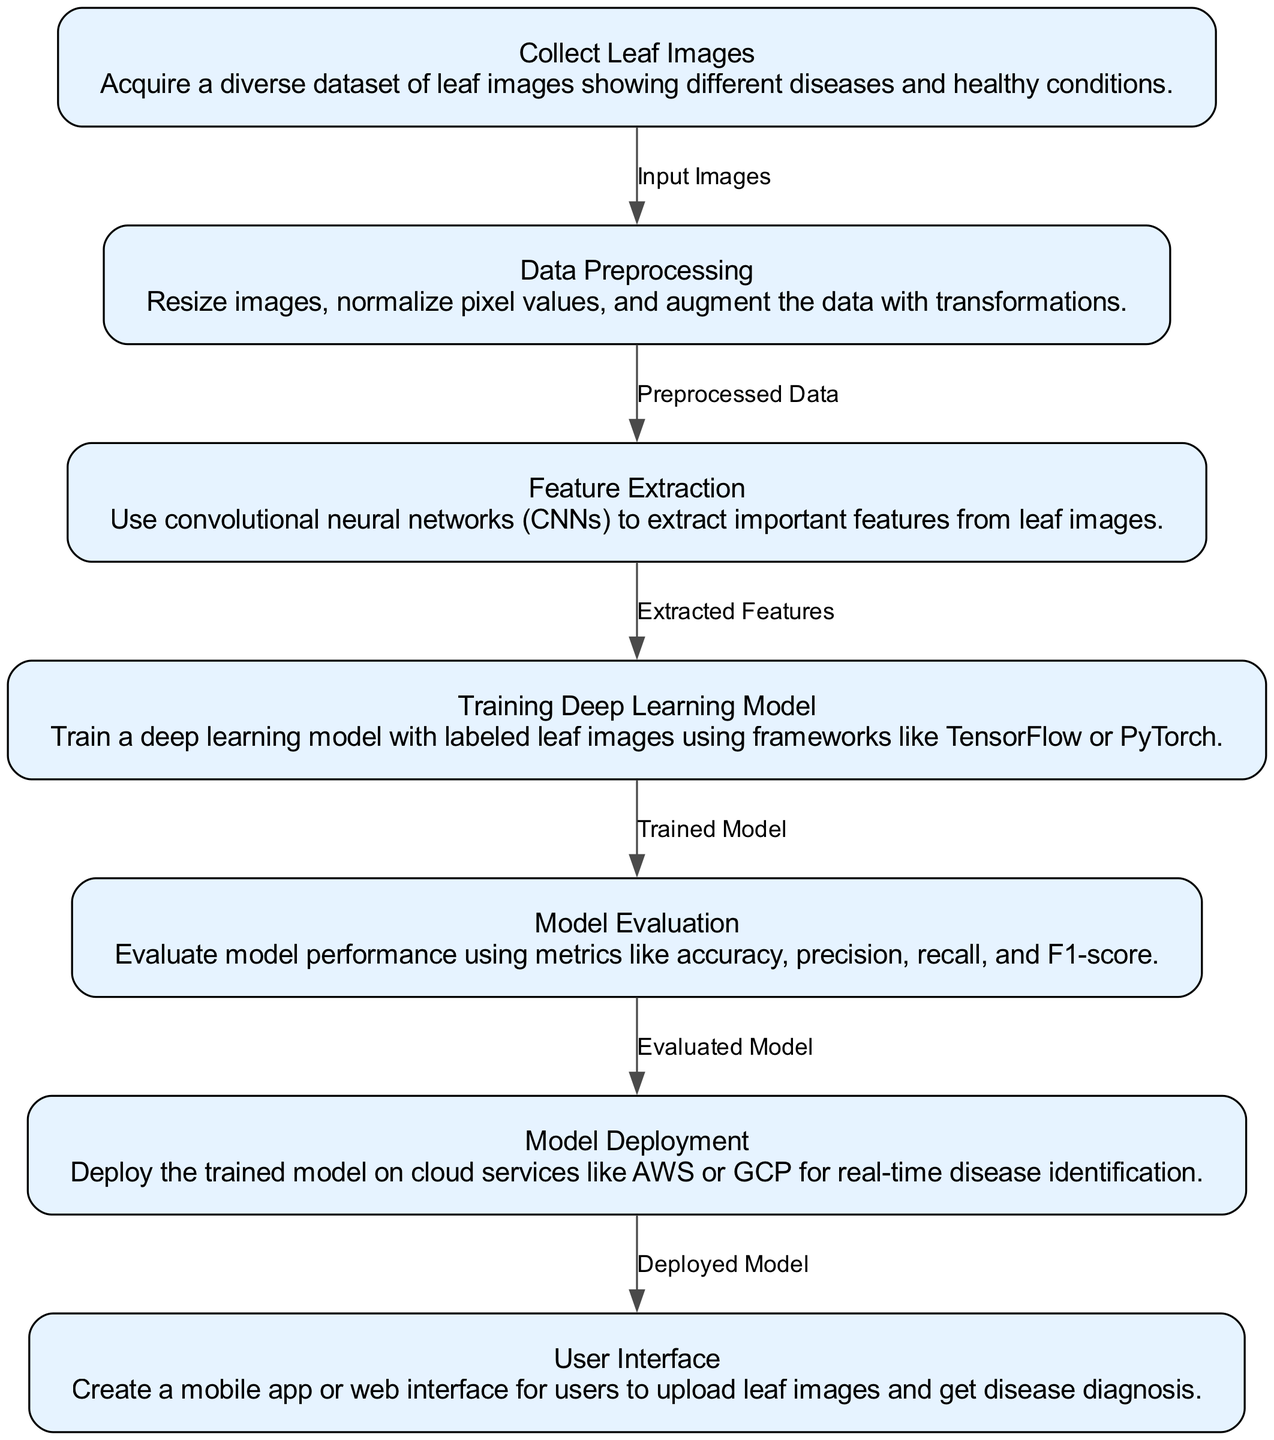What is the first step in the diagram? The first step in the diagram is "Collect Leaf Images", indicating that acquiring images is the initial action in the workflow.
Answer: Collect Leaf Images How many nodes are there in the diagram? By counting all the distinct steps shown in the diagram, there are a total of seven nodes representing different stages.
Answer: 7 What is the output of the "Data Preprocessing" node? The output of the "Data Preprocessing" node is "Preprocessed Data", which represents the transformed images ready for the next step in the process.
Answer: Preprocessed Data Which node comes after "Model Evaluation"? The node that comes after "Model Evaluation" is "Model Deployment", showing the progression from evaluating the model to deploying it for practical use.
Answer: Model Deployment What technique is used in "Feature Extraction"? The technique used in "Feature Extraction" is "convolutional neural networks (CNNs)", which are specifically designed for processing image data to extract features.
Answer: convolutional neural networks What are the metrics mentioned for "Model Evaluation"? The metrics mentioned for "Model Evaluation" include accuracy, precision, recall, and F1-score, all of which are crucial for assessing the model's performance.
Answer: accuracy, precision, recall, and F1-score What does the "User Interface" node allow users to do? The "User Interface" node allows users to upload leaf images and get disease diagnosis, highlighting its role as an interaction point for end-users.
Answer: upload leaf images and get disease diagnosis Describe the flow from "Training Deep Learning Model" to "Model Evaluation". The flow from "Training Deep Learning Model" to "Model Evaluation" indicates that after the model is trained with labeled data, it is then evaluated for its performance using specific metrics.
Answer: trained model to evaluated model Which cloud services are suggested for "Model Deployment"? The suggested cloud services for "Model Deployment" are AWS or GCP, which are commonly used platforms for hosting machine learning models.
Answer: AWS or GCP 